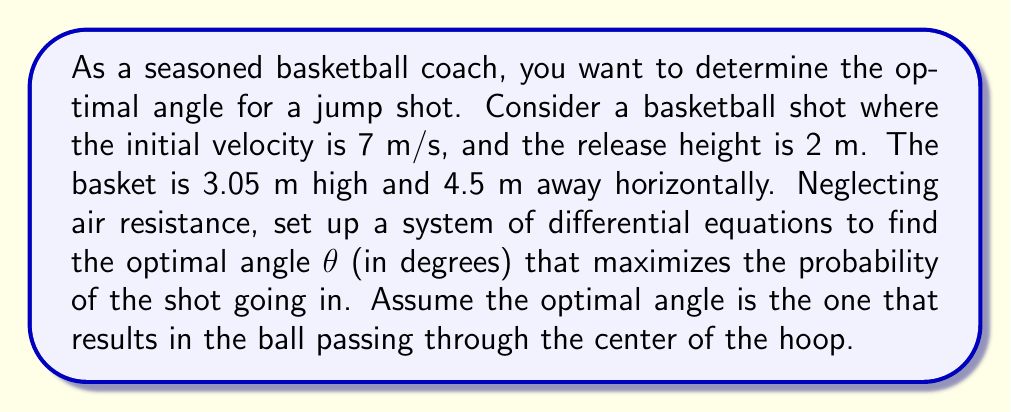Solve this math problem. Let's approach this step-by-step:

1) First, we need to set up our coordinate system. Let's use x for horizontal distance and y for vertical distance.

2) The equations of motion for projectile motion are:

   $$\frac{d^2x}{dt^2} = 0$$
   $$\frac{d^2y}{dt^2} = -g$$

   where g is the acceleration due to gravity (9.8 m/s²).

3) Integrating these equations once, we get:

   $$\frac{dx}{dt} = v_0 \cos(\theta)$$
   $$\frac{dy}{dt} = v_0 \sin(\theta) - gt$$

   where $v_0$ is the initial velocity (7 m/s) and θ is the angle we're trying to optimize.

4) Integrating again:

   $$x = v_0 t \cos(\theta)$$
   $$y = v_0 t \sin(\theta) - \frac{1}{2}gt^2 + y_0$$

   where $y_0$ is the initial height (2 m).

5) We want the ball to pass through the center of the hoop, so at some time t:

   $$x = 4.5$$
   $$y = 3.05$$

6) From the x equation:

   $$t = \frac{4.5}{v_0 \cos(\theta)}$$

7) Substituting this into the y equation:

   $$3.05 = v_0 (\frac{4.5}{v_0 \cos(\theta)}) \sin(\theta) - \frac{1}{2}g(\frac{4.5}{v_0 \cos(\theta)})^2 + 2$$

8) Simplifying and rearranging:

   $$1.05 = 4.5 \tan(\theta) - \frac{g(4.5)^2}{2v_0^2 \cos^2(\theta)}$$

9) This equation can be solved numerically for θ. Using a numerical solver, we find:

   $$\theta \approx 50.7°$$

This angle maximizes the probability of the shot going in by ensuring the ball passes through the center of the hoop.
Answer: The optimal angle for the basketball shot is approximately 50.7°. 